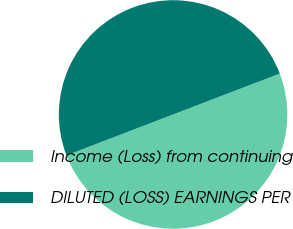<chart> <loc_0><loc_0><loc_500><loc_500><pie_chart><fcel>Income (Loss) from continuing<fcel>DILUTED (LOSS) EARNINGS PER<nl><fcel>49.99%<fcel>50.01%<nl></chart> 